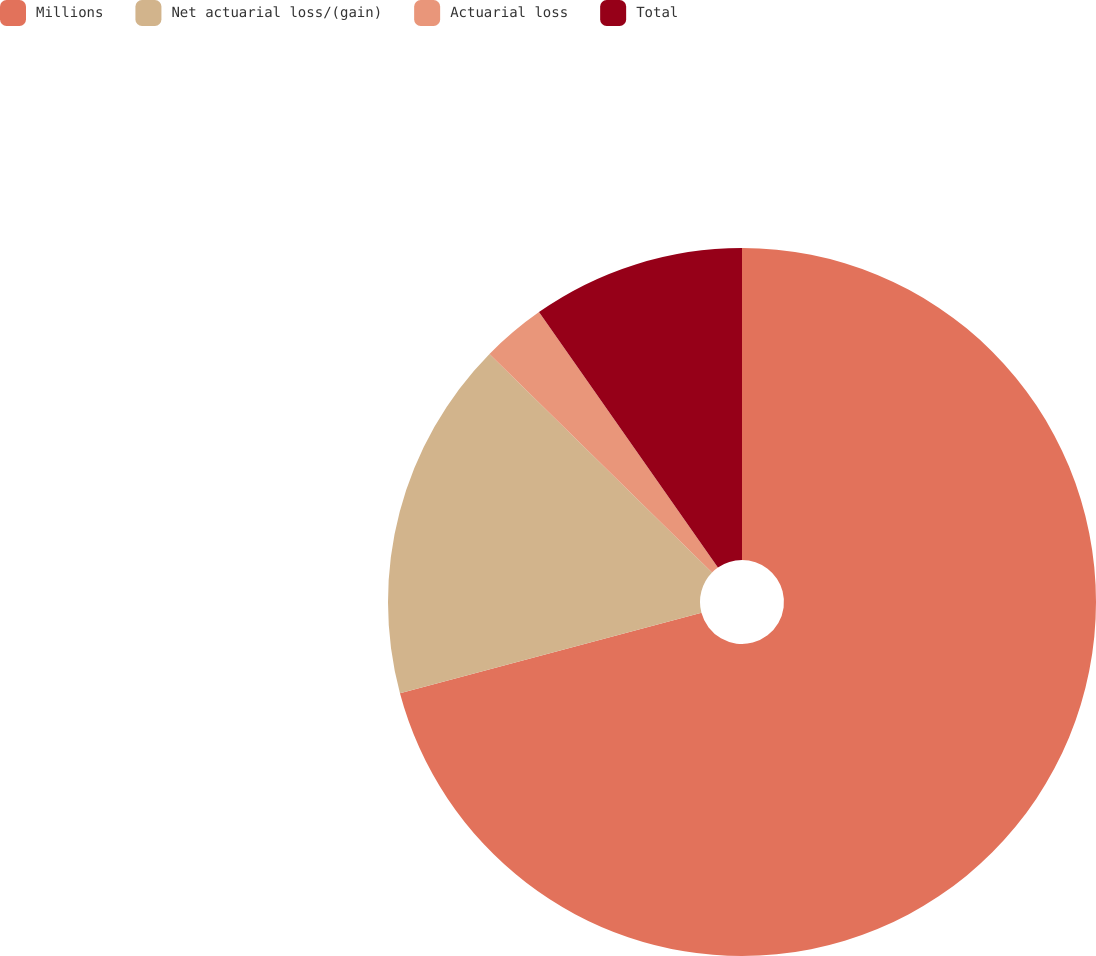<chart> <loc_0><loc_0><loc_500><loc_500><pie_chart><fcel>Millions<fcel>Net actuarial loss/(gain)<fcel>Actuarial loss<fcel>Total<nl><fcel>70.85%<fcel>16.51%<fcel>2.92%<fcel>9.72%<nl></chart> 